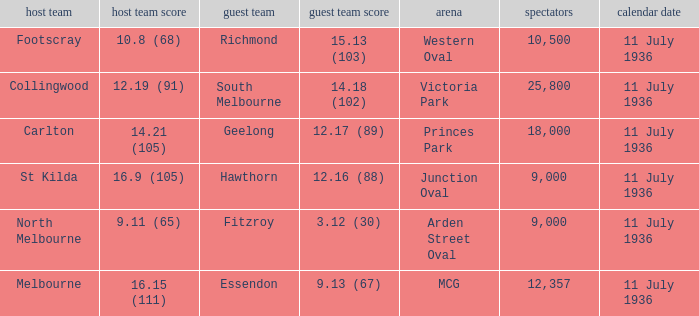What is the lowest crowd seen by the mcg Venue? 12357.0. 